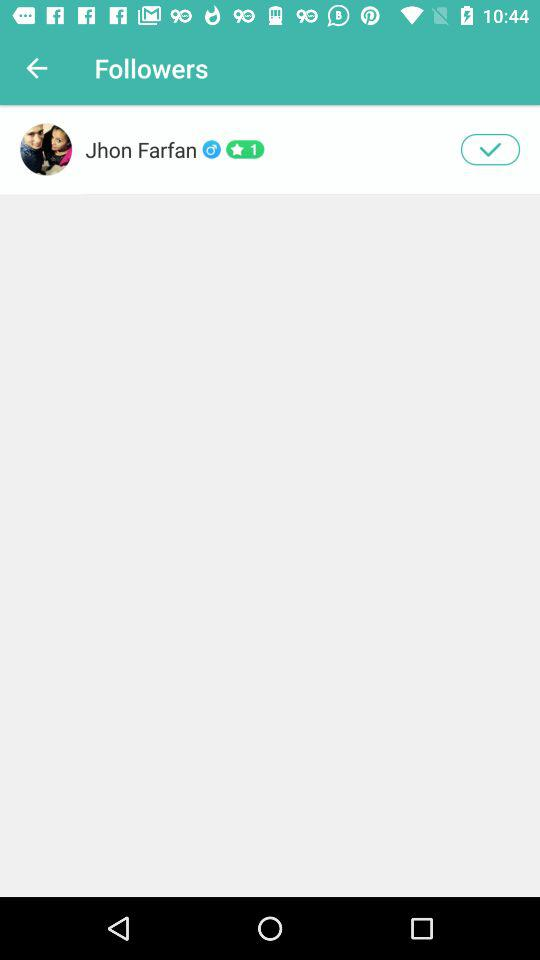What's the name of the followers? The name of the follower is Jhon Farfan. 